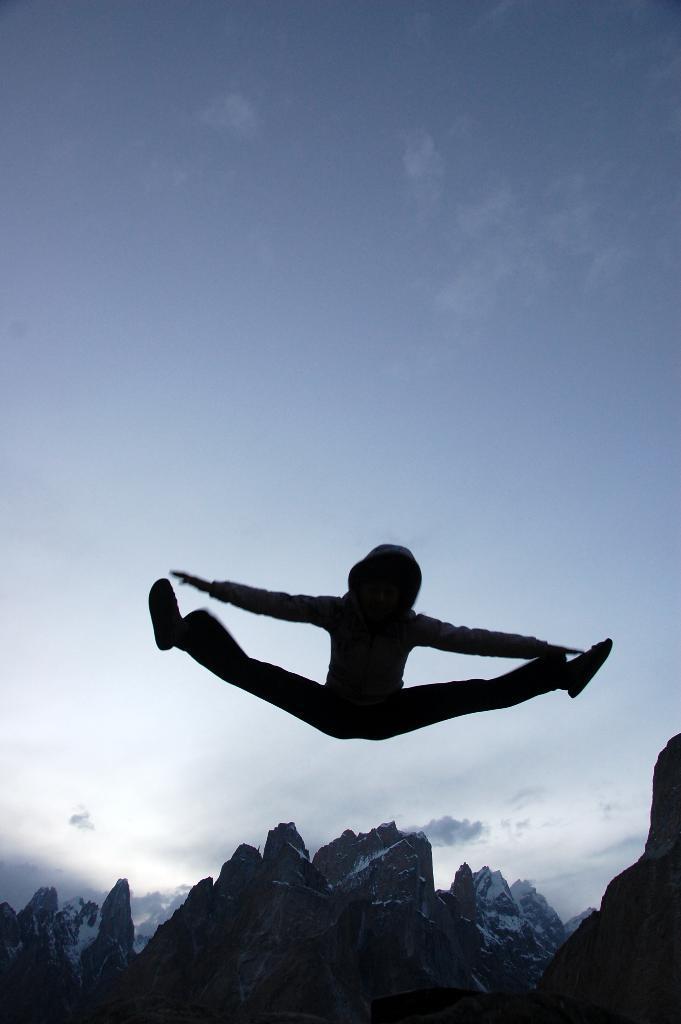In one or two sentences, can you explain what this image depicts? In this image I can see the person in air, background I can see mountains and sky in blue and white color. 